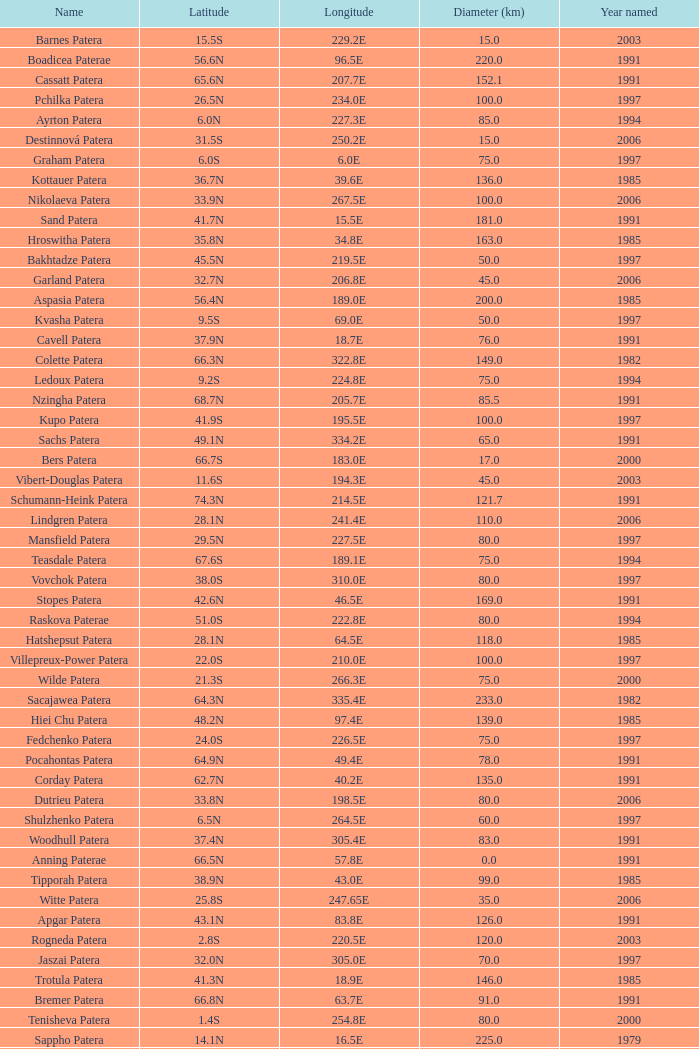What is the average Year Named, when Latitude is 37.9N, and when Diameter (km) is greater than 76? None. 